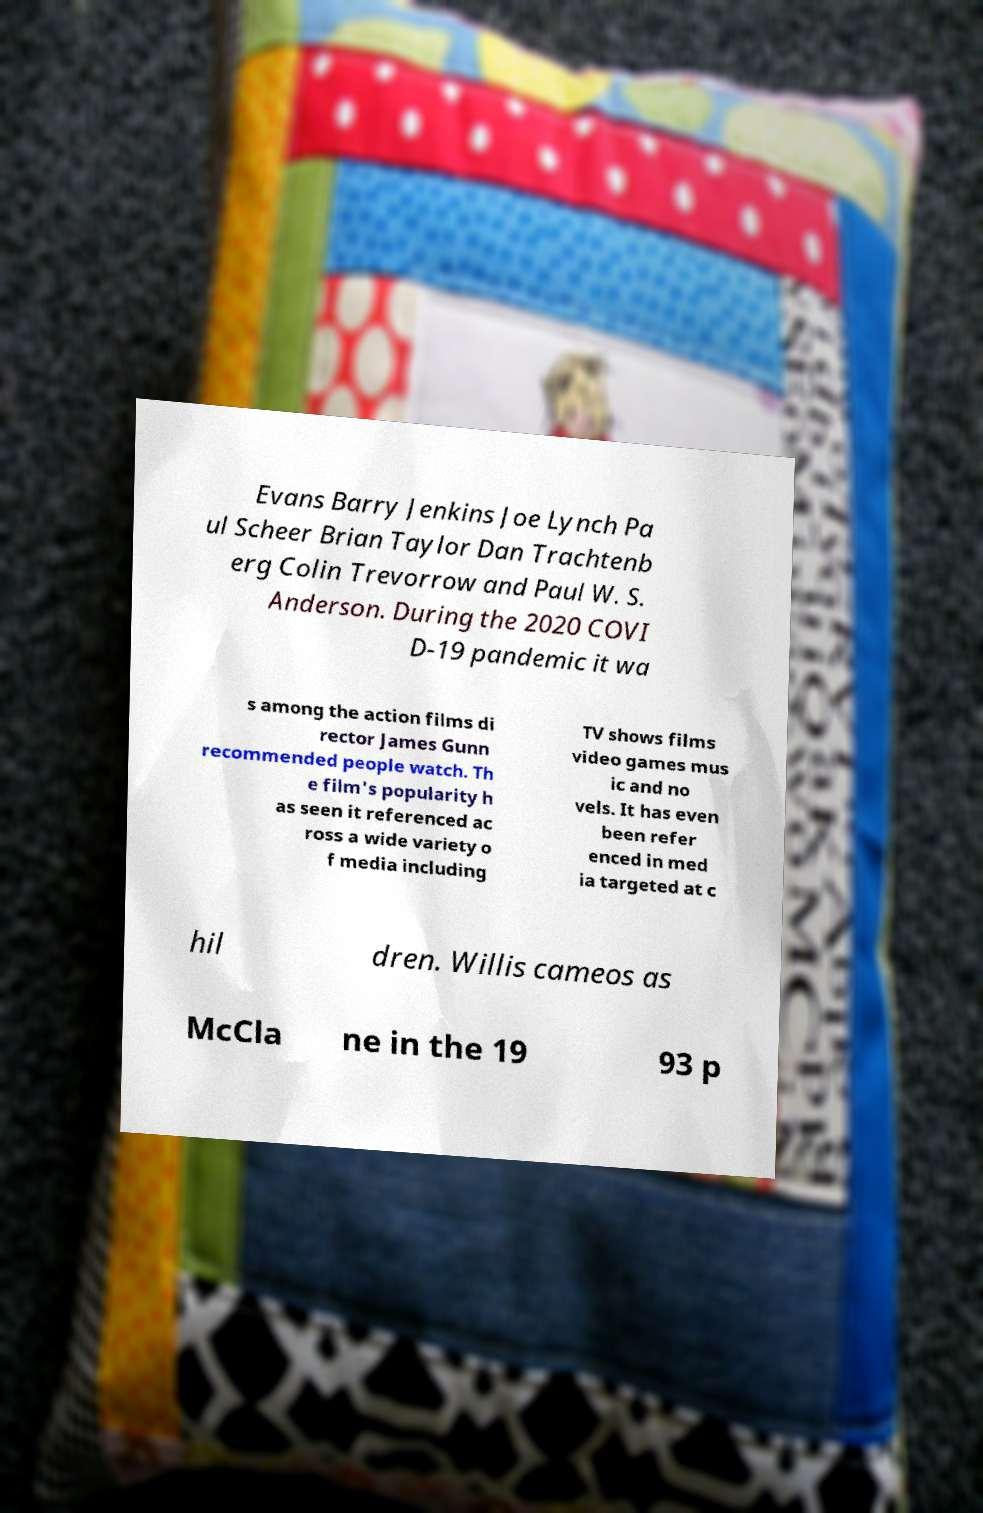What messages or text are displayed in this image? I need them in a readable, typed format. Evans Barry Jenkins Joe Lynch Pa ul Scheer Brian Taylor Dan Trachtenb erg Colin Trevorrow and Paul W. S. Anderson. During the 2020 COVI D-19 pandemic it wa s among the action films di rector James Gunn recommended people watch. Th e film's popularity h as seen it referenced ac ross a wide variety o f media including TV shows films video games mus ic and no vels. It has even been refer enced in med ia targeted at c hil dren. Willis cameos as McCla ne in the 19 93 p 